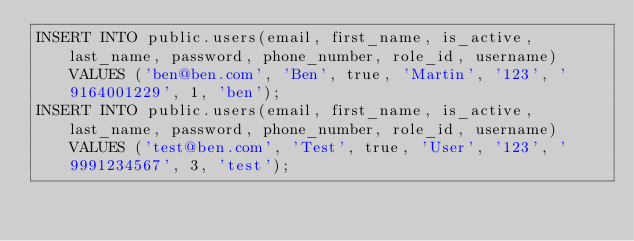<code> <loc_0><loc_0><loc_500><loc_500><_SQL_>INSERT INTO public.users(email, first_name, is_active, last_name, password, phone_number, role_id, username) VALUES ('ben@ben.com', 'Ben', true, 'Martin', '123', '9164001229', 1, 'ben');
INSERT INTO public.users(email, first_name, is_active, last_name, password, phone_number, role_id, username) VALUES ('test@ben.com', 'Test', true, 'User', '123', '9991234567', 3, 'test');</code> 